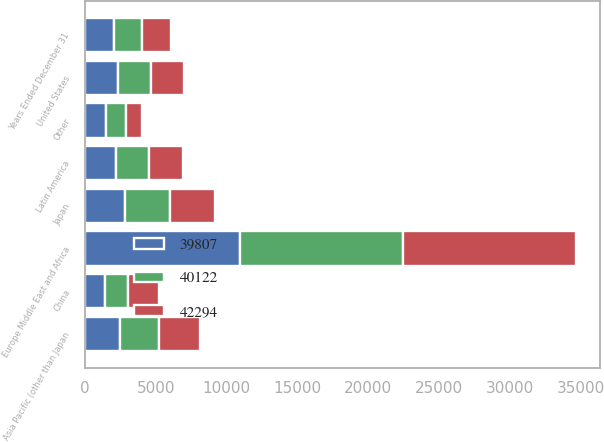Convert chart. <chart><loc_0><loc_0><loc_500><loc_500><stacked_bar_chart><ecel><fcel>Years Ended December 31<fcel>United States<fcel>Europe Middle East and Africa<fcel>Japan<fcel>Asia Pacific (other than Japan<fcel>Latin America<fcel>China<fcel>Other<nl><fcel>42294<fcel>2018<fcel>2339<fcel>12213<fcel>3212<fcel>2909<fcel>2415<fcel>2184<fcel>1149<nl><fcel>40122<fcel>2017<fcel>2339<fcel>11478<fcel>3122<fcel>2751<fcel>2339<fcel>1586<fcel>1422<nl><fcel>39807<fcel>2016<fcel>2339<fcel>10953<fcel>2846<fcel>2483<fcel>2155<fcel>1435<fcel>1457<nl></chart> 